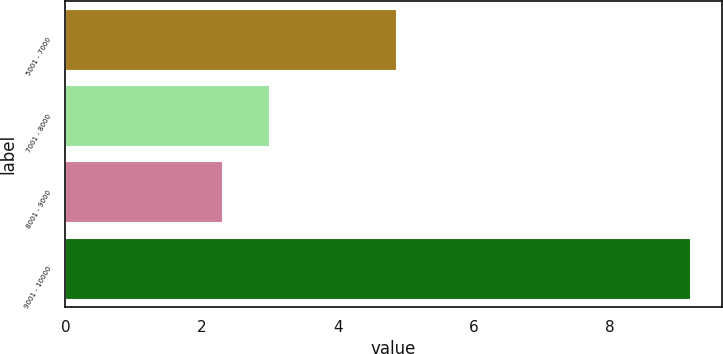Convert chart. <chart><loc_0><loc_0><loc_500><loc_500><bar_chart><fcel>5001 - 7000<fcel>7001 - 8000<fcel>8001 - 9000<fcel>9001 - 10000<nl><fcel>4.85<fcel>2.99<fcel>2.3<fcel>9.18<nl></chart> 